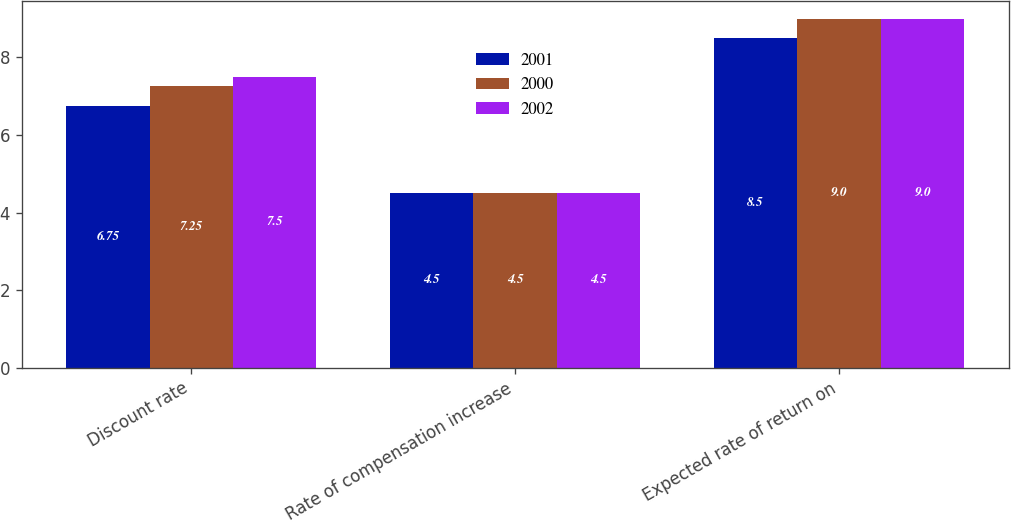Convert chart to OTSL. <chart><loc_0><loc_0><loc_500><loc_500><stacked_bar_chart><ecel><fcel>Discount rate<fcel>Rate of compensation increase<fcel>Expected rate of return on<nl><fcel>2001<fcel>6.75<fcel>4.5<fcel>8.5<nl><fcel>2000<fcel>7.25<fcel>4.5<fcel>9<nl><fcel>2002<fcel>7.5<fcel>4.5<fcel>9<nl></chart> 